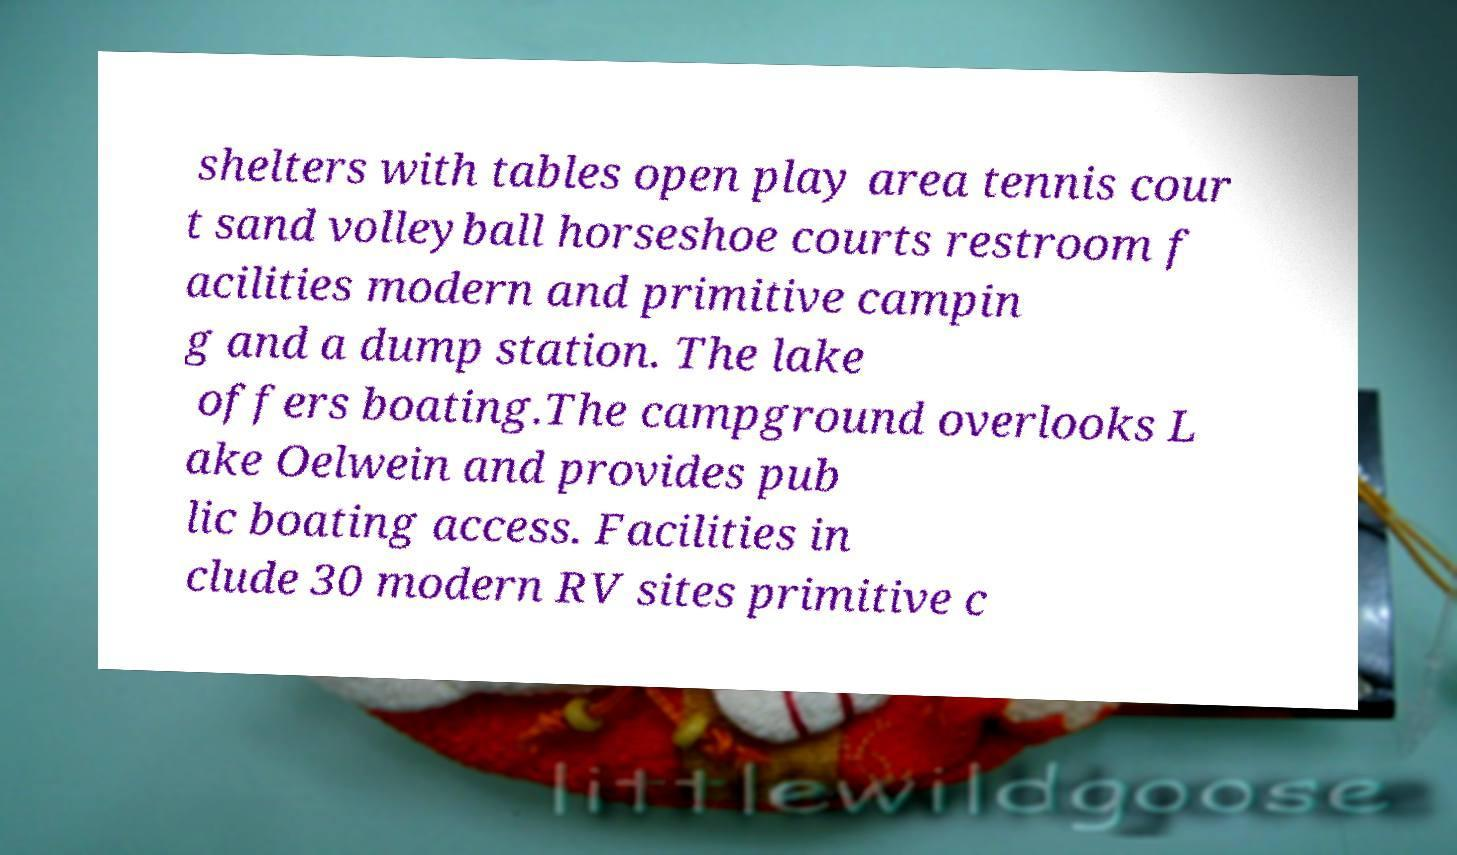Could you assist in decoding the text presented in this image and type it out clearly? shelters with tables open play area tennis cour t sand volleyball horseshoe courts restroom f acilities modern and primitive campin g and a dump station. The lake offers boating.The campground overlooks L ake Oelwein and provides pub lic boating access. Facilities in clude 30 modern RV sites primitive c 